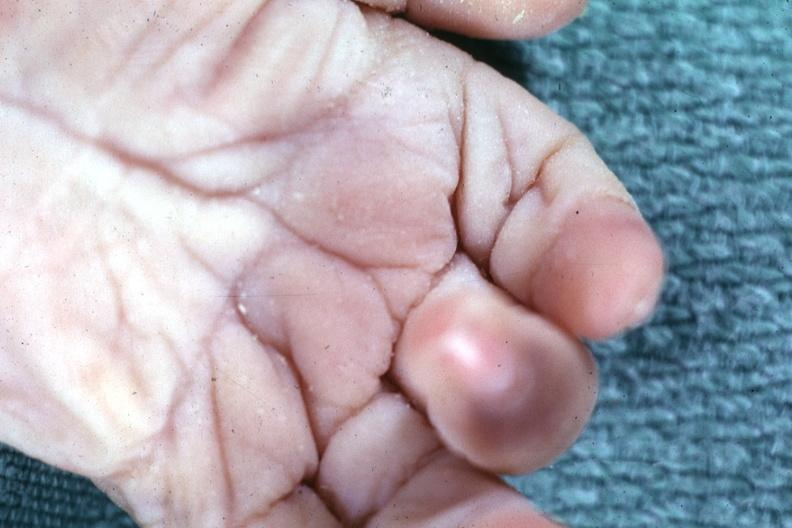what is present?
Answer the question using a single word or phrase. Hand 